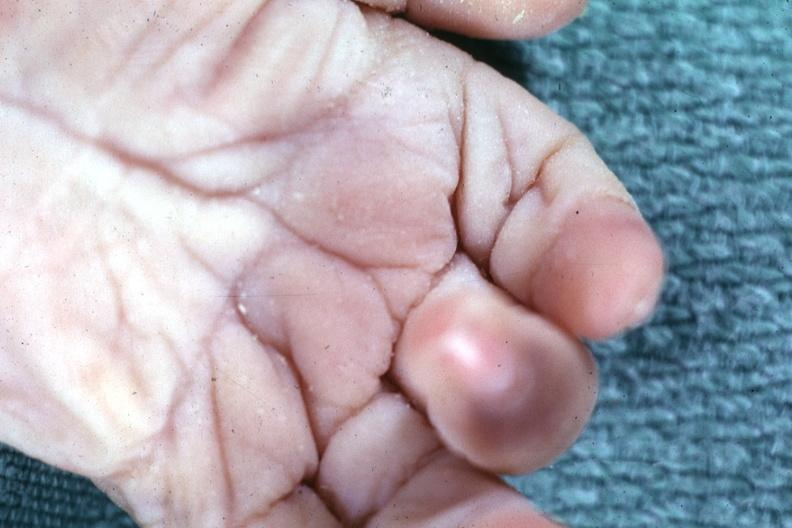what is present?
Answer the question using a single word or phrase. Hand 